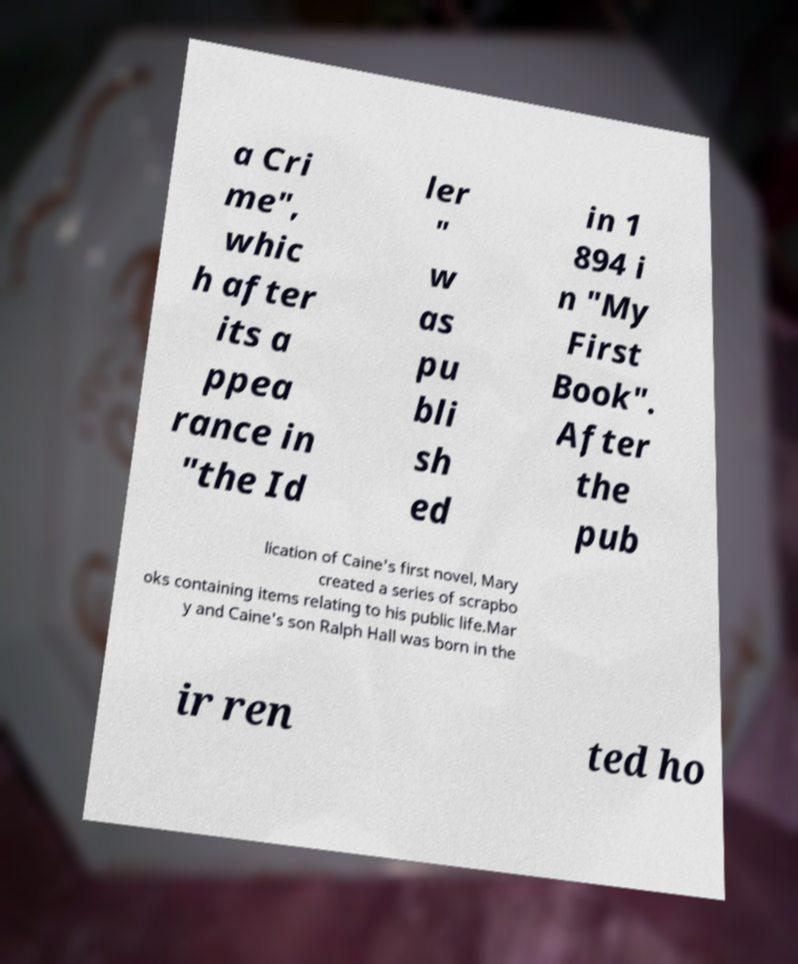Can you read and provide the text displayed in the image?This photo seems to have some interesting text. Can you extract and type it out for me? a Cri me", whic h after its a ppea rance in "the Id ler " w as pu bli sh ed in 1 894 i n "My First Book". After the pub lication of Caine's first novel, Mary created a series of scrapbo oks containing items relating to his public life.Mar y and Caine's son Ralph Hall was born in the ir ren ted ho 